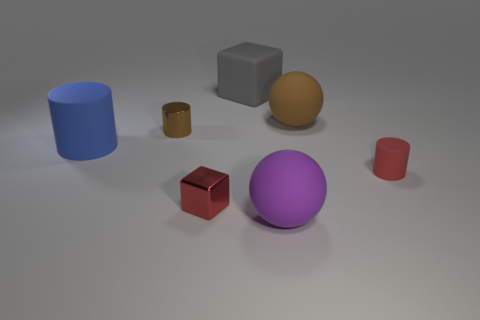Subtract all small brown cylinders. How many cylinders are left? 2 Add 2 blue rubber spheres. How many objects exist? 9 Subtract all cylinders. How many objects are left? 4 Add 7 large balls. How many large balls exist? 9 Subtract 0 red spheres. How many objects are left? 7 Subtract all tiny red matte objects. Subtract all big gray rubber cylinders. How many objects are left? 6 Add 4 small metal cylinders. How many small metal cylinders are left? 5 